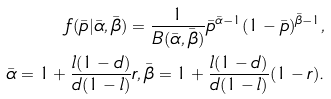<formula> <loc_0><loc_0><loc_500><loc_500>f ( \bar { p } | \bar { \alpha } , \bar { \beta } ) = \frac { 1 } { B ( \bar { \alpha } , \bar { \beta } ) } \bar { p } ^ { \bar { \alpha } - 1 } ( 1 - \bar { p } ) ^ { \bar { \beta } - 1 } , \\ \bar { \alpha } = 1 + \frac { l ( 1 - d ) } { d ( 1 - l ) } r , \bar { \beta } = 1 + \frac { l ( 1 - d ) } { d ( 1 - l ) } ( 1 - r ) .</formula> 